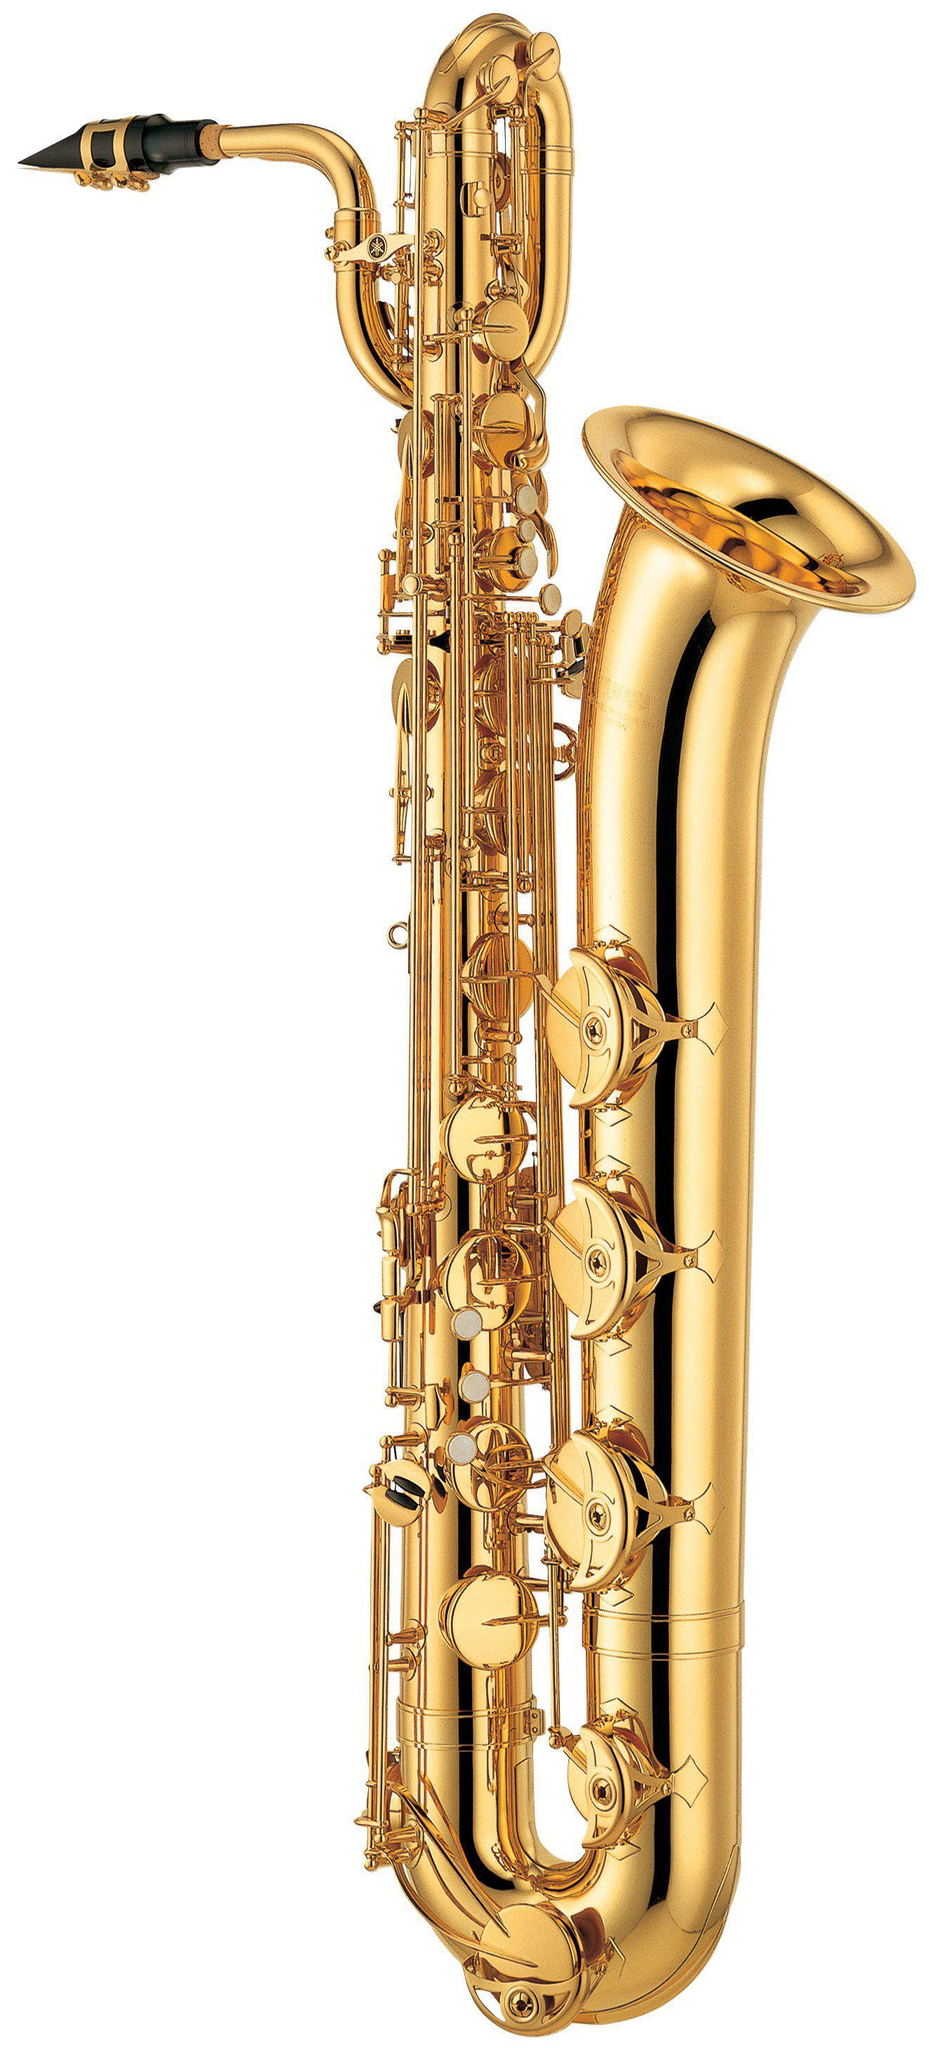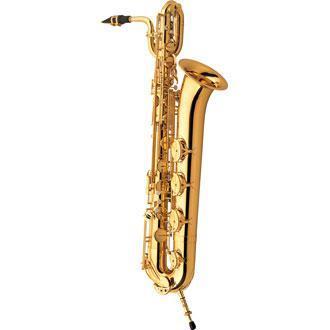The first image is the image on the left, the second image is the image on the right. For the images shown, is this caption "In at least one image that is a golden brass saxophone  with a black and gold mouth pieces." true? Answer yes or no. Yes. The first image is the image on the left, the second image is the image on the right. Evaluate the accuracy of this statement regarding the images: "Each image shows one upright gold colored saxophone with its bell facing rightward and its black-tipped mouthpiece facing leftward.". Is it true? Answer yes or no. Yes. 